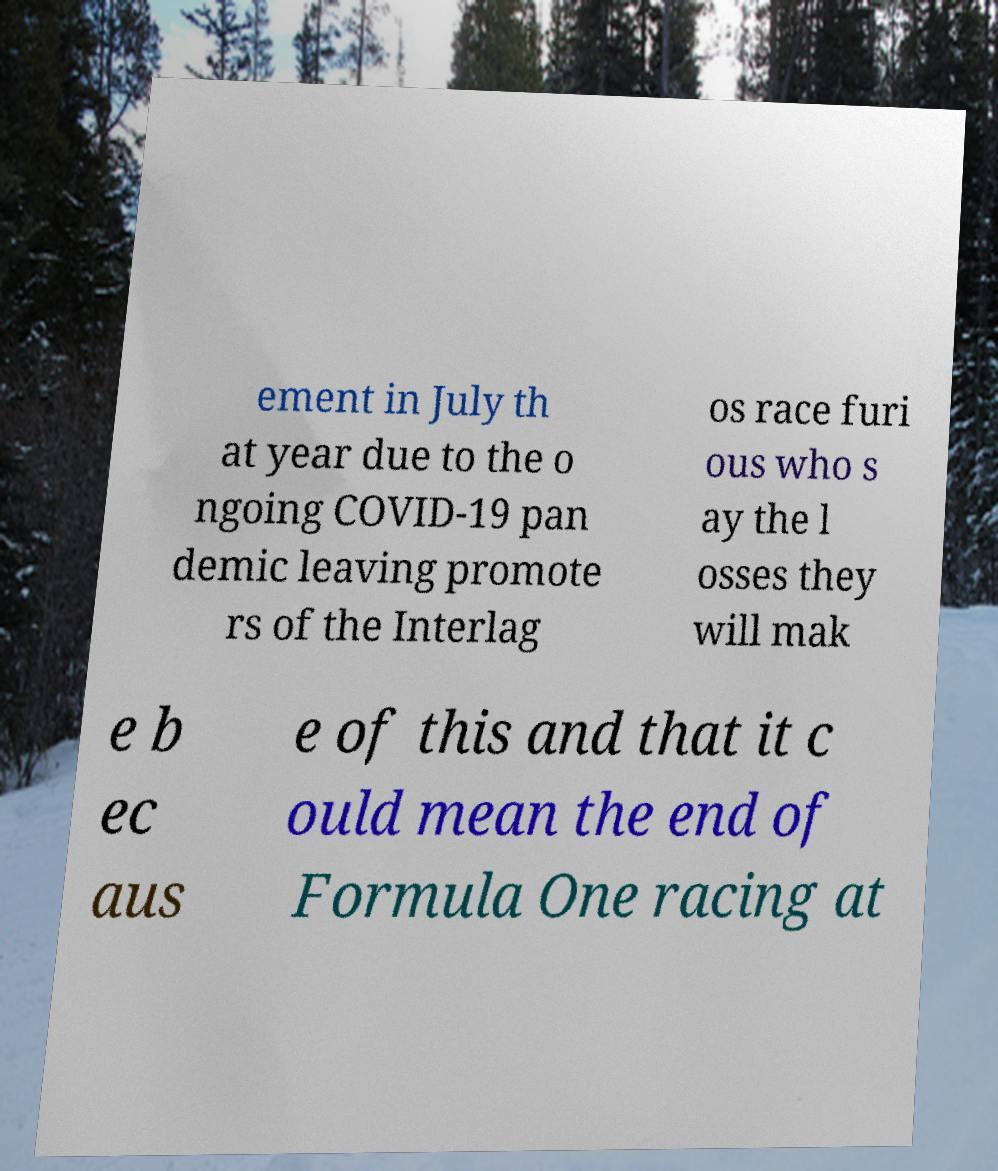I need the written content from this picture converted into text. Can you do that? ement in July th at year due to the o ngoing COVID-19 pan demic leaving promote rs of the Interlag os race furi ous who s ay the l osses they will mak e b ec aus e of this and that it c ould mean the end of Formula One racing at 